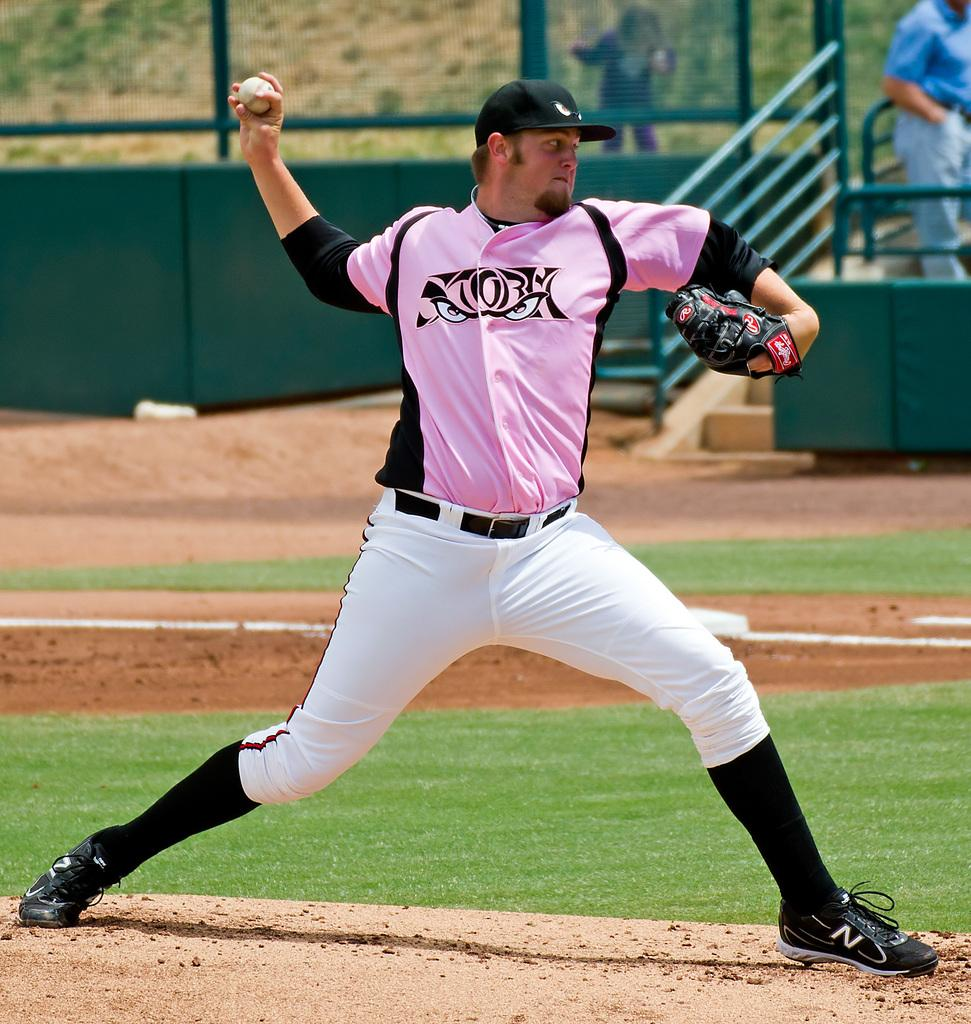Provide a one-sentence caption for the provided image. baseball player in a pink shirt has a mitt on his left hand branded with a R in a small red circle. 